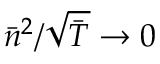<formula> <loc_0><loc_0><loc_500><loc_500>\bar { n } ^ { 2 } / \sqrt { \bar { T } } \rightarrow 0</formula> 